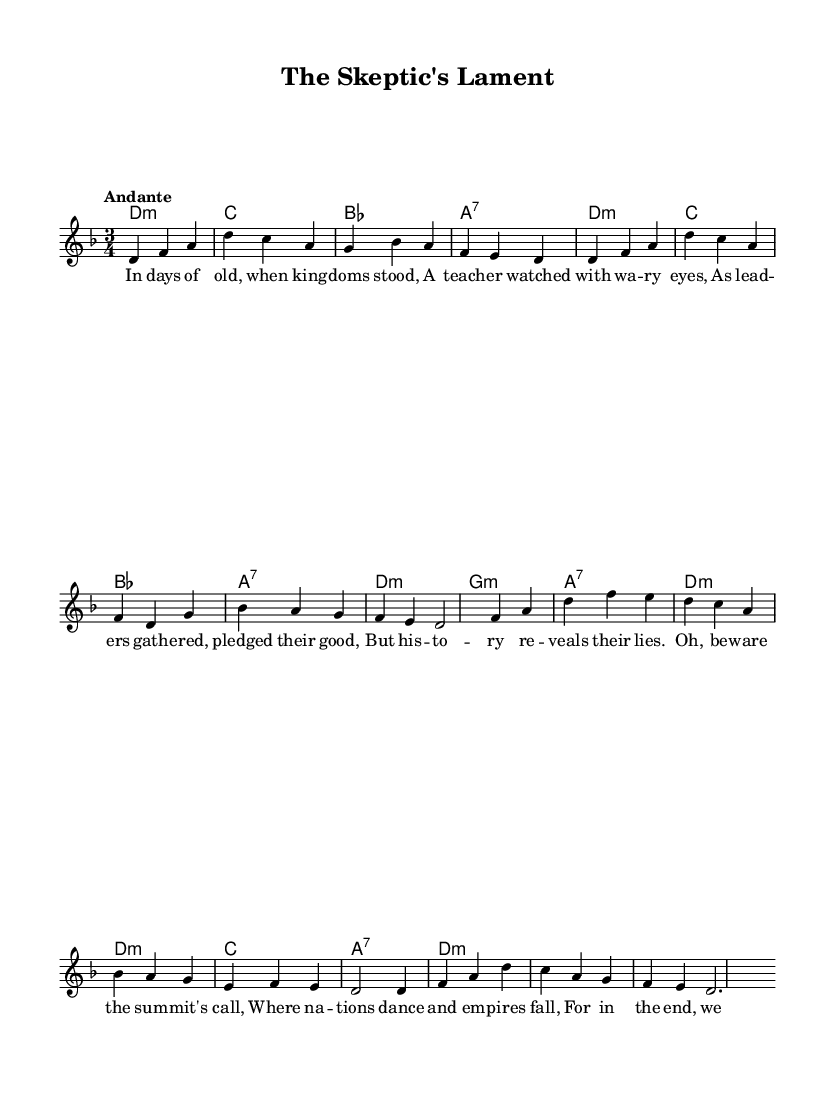What is the key signature of this music? The key signature is D minor, which includes one flat (B flat). We determine this from the \key d \minor instruction in the global context of the sheet music.
Answer: D minor What is the time signature of this music? The time signature is 3/4, indicated by the \time 3/4 command in the global section. This means there are three beats in each measure and the quarter note gets one beat.
Answer: 3/4 What is the tempo marking for this piece? The tempo marking is "Andante," which is stated in the global section. This generally indicates a moderately slow pace.
Answer: Andante How many measures are in the chorus? There are four measures in the chorus as seen in the structure of the music where it is distinct from the verse. Each line of lyrics corresponds to one measure, and there are four lines in the chorus.
Answer: 4 What do the lyrics primarily discuss? The lyrics primarily discuss skepticism regarding leaders and alliances, reflecting a historical context of distrust and individual observation. This is inferred from the words "A teacher watched with wary eyes," indicating a critical viewpoint of political gatherings.
Answer: Skepticism Which chord appears most frequently in the harmonies? The D minor chord (notated as d2.:m) appears most frequently in the harmonies, occurring four times in the given chord progression. This indicates its importance in setting the mood of the piece.
Answer: D minor What narrative theme does this ballad revolve around? The narrative theme revolves around individual heroism and resistance against collective agreements, as suggested by phrases like "Oh, beware the summit's call" and the historical undertones in the lyrics.
Answer: Individual heroism 